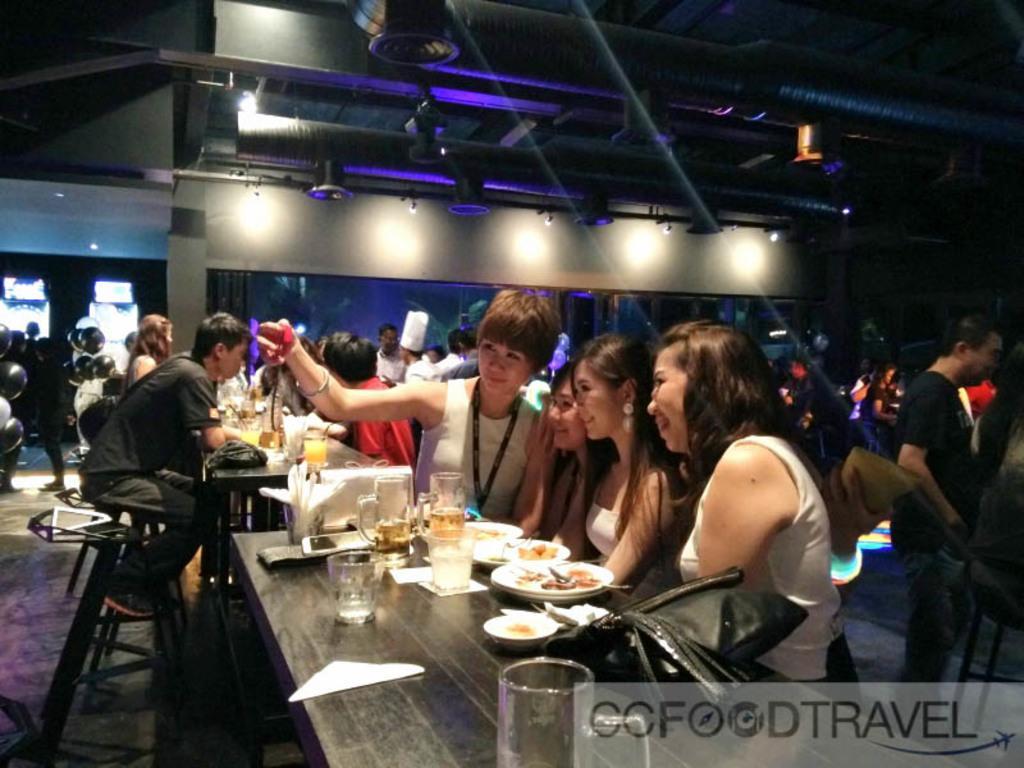Describe this image in one or two sentences. In the foreground of this image, there are four women standing and taking selfie in front of a table on which, there are glasses, mugs, platters with food, bowl, tissues, mobile phone and a bag. In the background, there are people standing and sitting, we can also see few objects on the table, wall, lights, few balloon like objects and pipes at the top. 